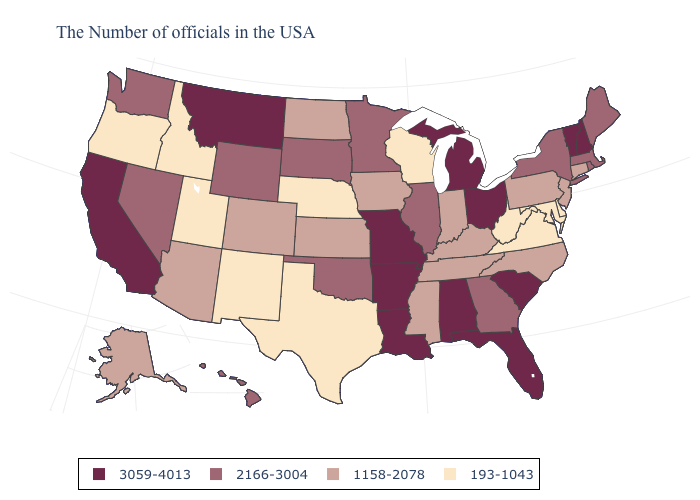What is the value of Florida?
Answer briefly. 3059-4013. What is the value of California?
Short answer required. 3059-4013. Name the states that have a value in the range 193-1043?
Short answer required. Delaware, Maryland, Virginia, West Virginia, Wisconsin, Nebraska, Texas, New Mexico, Utah, Idaho, Oregon. What is the highest value in the South ?
Short answer required. 3059-4013. Among the states that border Louisiana , does Texas have the lowest value?
Be succinct. Yes. What is the value of Oregon?
Be succinct. 193-1043. Which states have the lowest value in the USA?
Be succinct. Delaware, Maryland, Virginia, West Virginia, Wisconsin, Nebraska, Texas, New Mexico, Utah, Idaho, Oregon. What is the value of New Hampshire?
Be succinct. 3059-4013. What is the value of Arkansas?
Give a very brief answer. 3059-4013. Name the states that have a value in the range 193-1043?
Concise answer only. Delaware, Maryland, Virginia, West Virginia, Wisconsin, Nebraska, Texas, New Mexico, Utah, Idaho, Oregon. Does Montana have the same value as Vermont?
Concise answer only. Yes. Does Rhode Island have the lowest value in the Northeast?
Give a very brief answer. No. Does Ohio have the same value as South Carolina?
Give a very brief answer. Yes. What is the value of Ohio?
Answer briefly. 3059-4013. What is the lowest value in states that border Wyoming?
Concise answer only. 193-1043. 